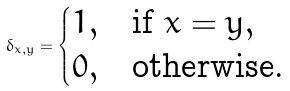<formula> <loc_0><loc_0><loc_500><loc_500>\delta _ { x , y } = \begin{cases} 1 , & \text {if } x = y , \\ 0 , & \text {otherwise.} \end{cases}</formula> 